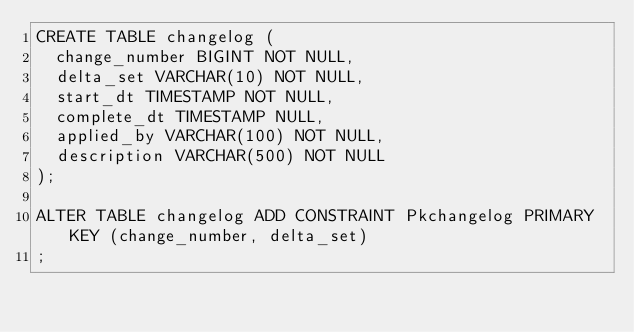<code> <loc_0><loc_0><loc_500><loc_500><_SQL_>CREATE TABLE changelog (
  change_number BIGINT NOT NULL,
  delta_set VARCHAR(10) NOT NULL,
  start_dt TIMESTAMP NOT NULL,
  complete_dt TIMESTAMP NULL,
  applied_by VARCHAR(100) NOT NULL,
  description VARCHAR(500) NOT NULL
);

ALTER TABLE changelog ADD CONSTRAINT Pkchangelog PRIMARY KEY (change_number, delta_set)
;</code> 